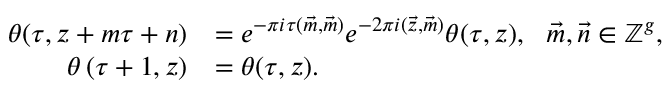<formula> <loc_0><loc_0><loc_500><loc_500>\begin{array} { r l } { \theta ( \tau , z + m \tau + n ) } & { = e ^ { - \pi i \tau ( \vec { m } , \vec { m } ) } e ^ { - 2 \pi i ( \vec { z } , \vec { m } ) } \theta ( \tau , z ) , \quad v e c { m } , \vec { n } \in \mathbb { Z } ^ { g } , } \\ { \theta \left ( \tau + 1 , z \right ) } & { = \theta ( \tau , z ) . } \end{array}</formula> 